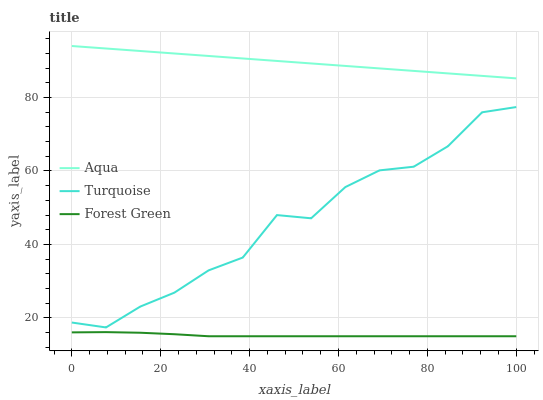Does Forest Green have the minimum area under the curve?
Answer yes or no. Yes. Does Aqua have the maximum area under the curve?
Answer yes or no. Yes. Does Aqua have the minimum area under the curve?
Answer yes or no. No. Does Forest Green have the maximum area under the curve?
Answer yes or no. No. Is Aqua the smoothest?
Answer yes or no. Yes. Is Turquoise the roughest?
Answer yes or no. Yes. Is Forest Green the smoothest?
Answer yes or no. No. Is Forest Green the roughest?
Answer yes or no. No. Does Aqua have the lowest value?
Answer yes or no. No. Does Aqua have the highest value?
Answer yes or no. Yes. Does Forest Green have the highest value?
Answer yes or no. No. Is Forest Green less than Turquoise?
Answer yes or no. Yes. Is Turquoise greater than Forest Green?
Answer yes or no. Yes. Does Forest Green intersect Turquoise?
Answer yes or no. No. 